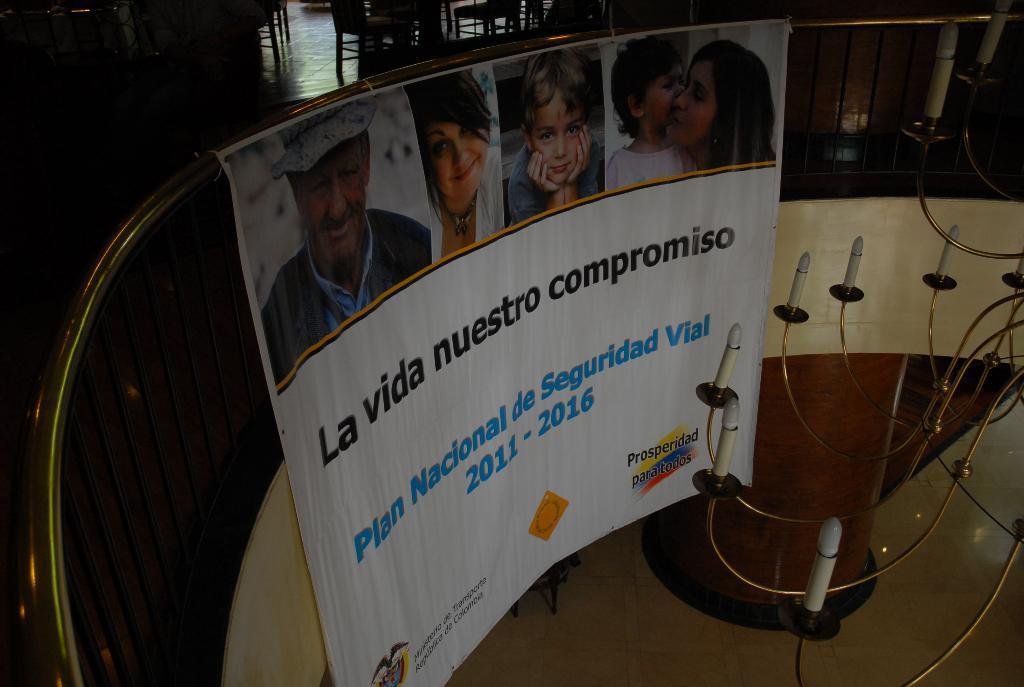Describe this image in one or two sentences. In this image we can see a fencing to which there is a fencing in which there are some pictures of people and something written on it and also we can see some lights. 